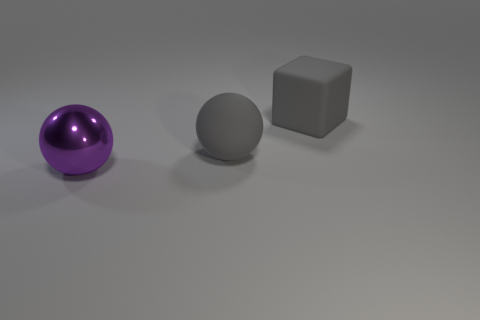How many things are either large cyan shiny cylinders or rubber things on the right side of the metal object?
Your answer should be compact. 2. Are there fewer purple balls than large red metallic cylinders?
Give a very brief answer. No. Are there more gray blocks than brown things?
Keep it short and to the point. Yes. What number of other objects are the same material as the big gray sphere?
Make the answer very short. 1. What number of big gray rubber things are in front of the big gray thing that is behind the large sphere right of the large purple thing?
Ensure brevity in your answer.  1. What number of metal objects are big red spheres or big gray balls?
Offer a very short reply. 0. There is a big object that is behind the big rubber sphere; is it the same color as the big rubber thing that is in front of the gray block?
Provide a short and direct response. Yes. The big thing that is in front of the rubber block and on the right side of the purple ball is what color?
Your answer should be compact. Gray. Does the gray ball have the same material as the block?
Provide a short and direct response. Yes. How many tiny things are either gray balls or red balls?
Offer a terse response. 0. 